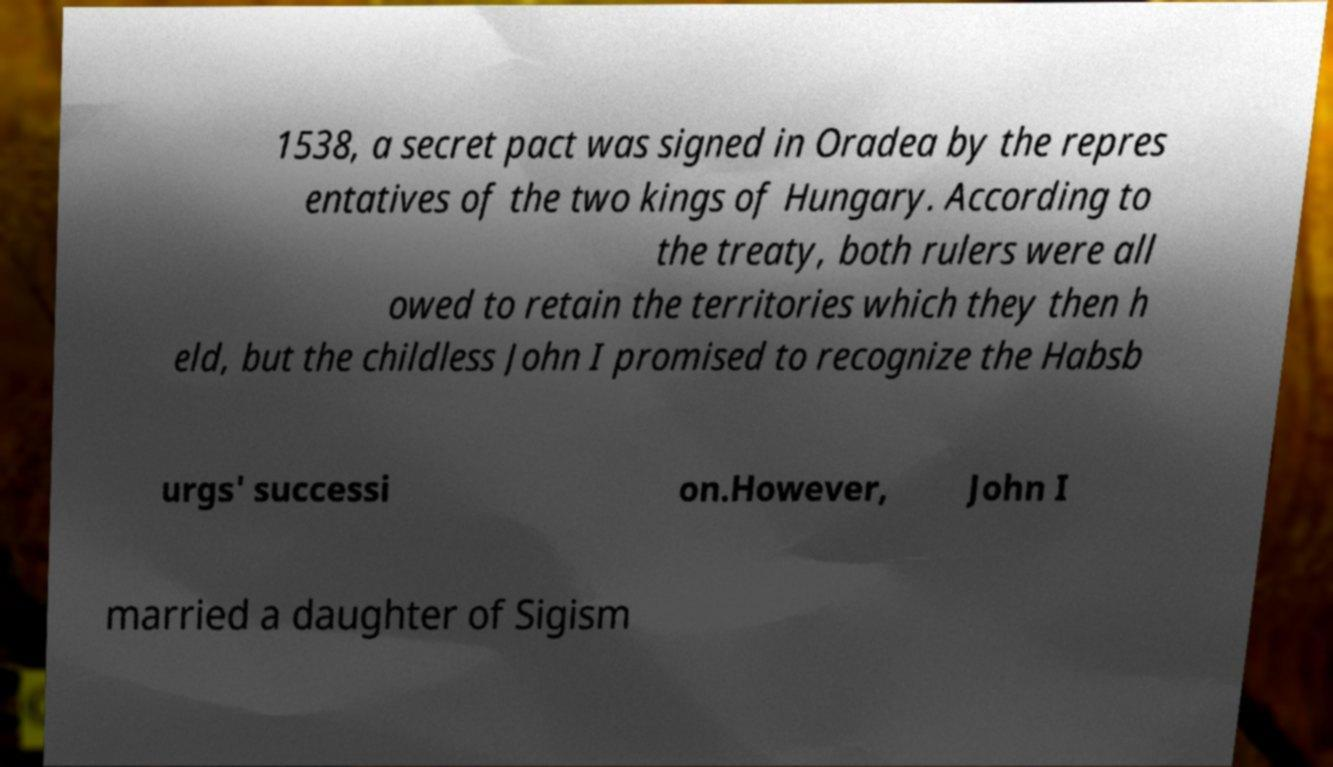Can you accurately transcribe the text from the provided image for me? 1538, a secret pact was signed in Oradea by the repres entatives of the two kings of Hungary. According to the treaty, both rulers were all owed to retain the territories which they then h eld, but the childless John I promised to recognize the Habsb urgs' successi on.However, John I married a daughter of Sigism 